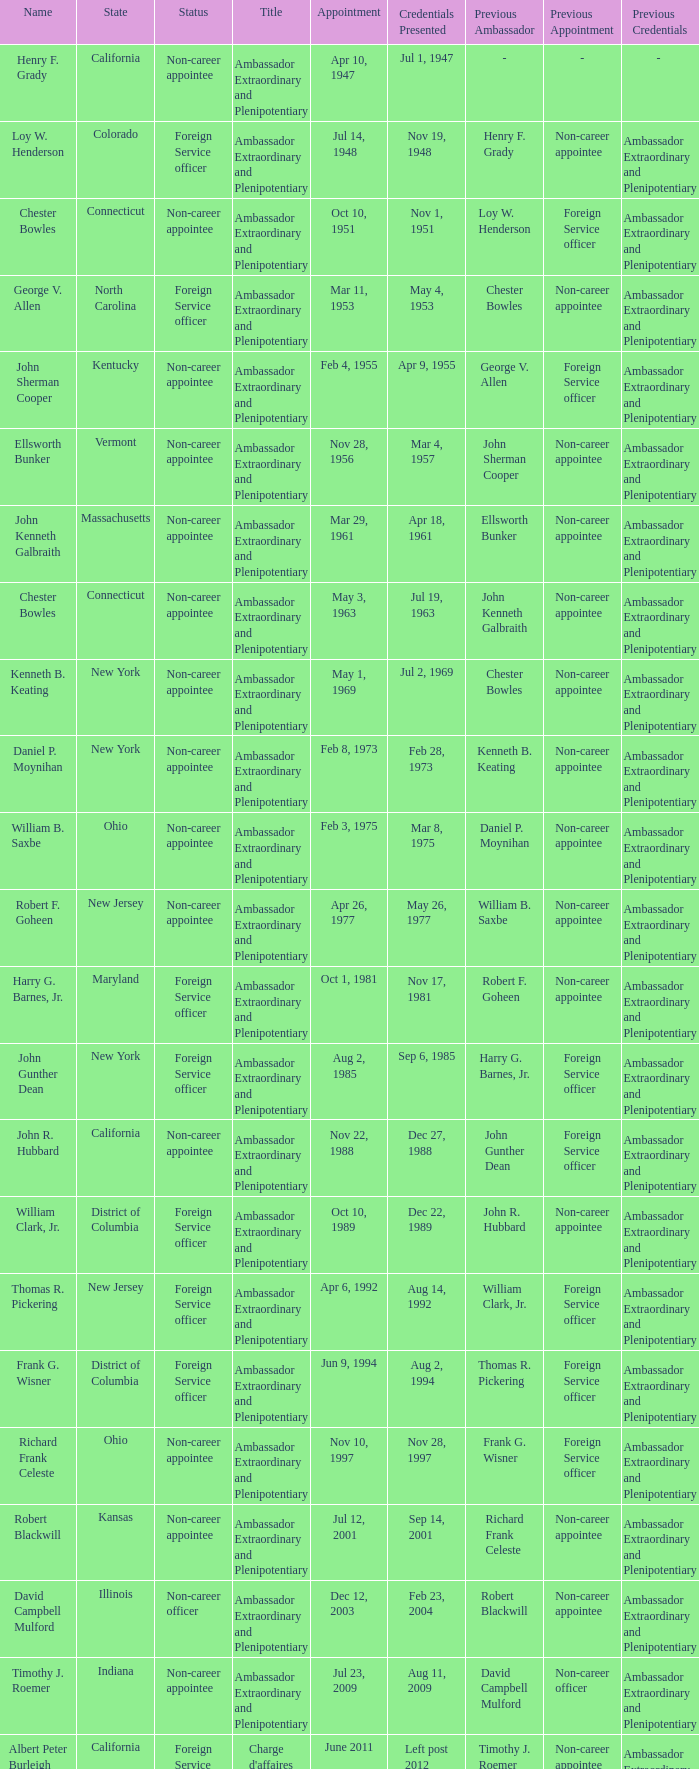What is the designation for david campbell mulford? Ambassador Extraordinary and Plenipotentiary. 